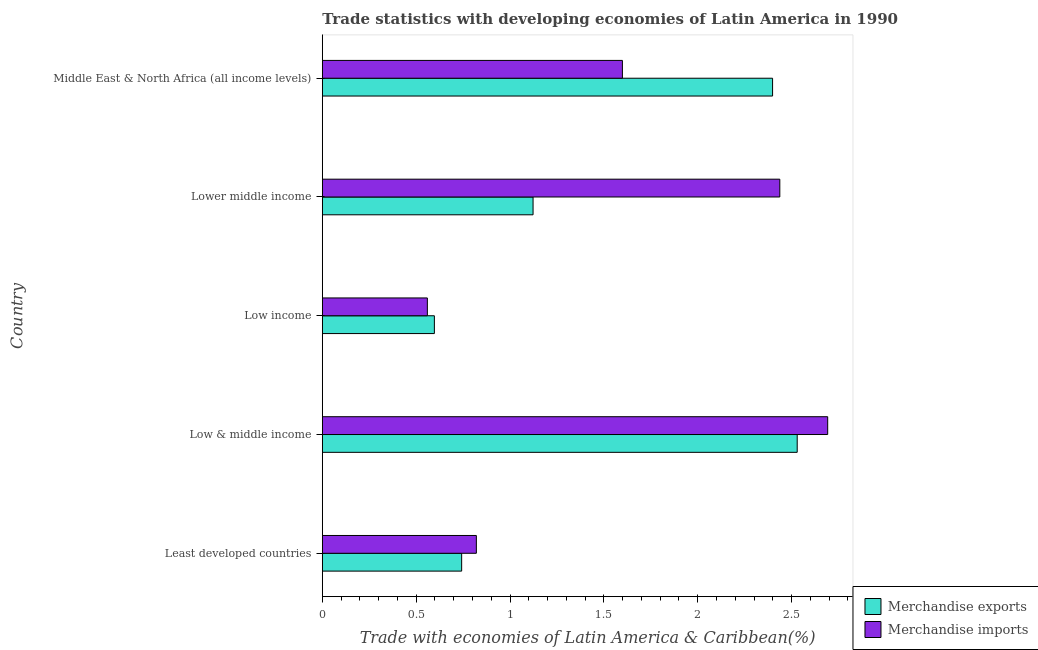How many groups of bars are there?
Ensure brevity in your answer.  5. How many bars are there on the 4th tick from the top?
Your response must be concise. 2. What is the label of the 1st group of bars from the top?
Ensure brevity in your answer.  Middle East & North Africa (all income levels). In how many cases, is the number of bars for a given country not equal to the number of legend labels?
Give a very brief answer. 0. What is the merchandise imports in Low income?
Provide a short and direct response. 0.56. Across all countries, what is the maximum merchandise imports?
Your answer should be compact. 2.69. Across all countries, what is the minimum merchandise exports?
Your response must be concise. 0.6. In which country was the merchandise exports minimum?
Your answer should be compact. Low income. What is the total merchandise exports in the graph?
Make the answer very short. 7.39. What is the difference between the merchandise exports in Least developed countries and that in Lower middle income?
Make the answer very short. -0.38. What is the difference between the merchandise exports in Least developed countries and the merchandise imports in Low income?
Give a very brief answer. 0.18. What is the average merchandise exports per country?
Your answer should be compact. 1.48. What is the difference between the merchandise exports and merchandise imports in Least developed countries?
Make the answer very short. -0.08. What is the ratio of the merchandise exports in Lower middle income to that in Middle East & North Africa (all income levels)?
Offer a terse response. 0.47. Is the difference between the merchandise exports in Low & middle income and Lower middle income greater than the difference between the merchandise imports in Low & middle income and Lower middle income?
Make the answer very short. Yes. What is the difference between the highest and the second highest merchandise exports?
Provide a succinct answer. 0.13. What is the difference between the highest and the lowest merchandise imports?
Provide a succinct answer. 2.13. What does the 1st bar from the top in Least developed countries represents?
Your answer should be compact. Merchandise imports. How many bars are there?
Your response must be concise. 10. How many countries are there in the graph?
Your answer should be very brief. 5. What is the difference between two consecutive major ticks on the X-axis?
Provide a short and direct response. 0.5. Are the values on the major ticks of X-axis written in scientific E-notation?
Ensure brevity in your answer.  No. Does the graph contain any zero values?
Offer a terse response. No. Does the graph contain grids?
Provide a succinct answer. No. Where does the legend appear in the graph?
Your answer should be compact. Bottom right. How many legend labels are there?
Provide a succinct answer. 2. What is the title of the graph?
Offer a terse response. Trade statistics with developing economies of Latin America in 1990. What is the label or title of the X-axis?
Offer a terse response. Trade with economies of Latin America & Caribbean(%). What is the label or title of the Y-axis?
Your response must be concise. Country. What is the Trade with economies of Latin America & Caribbean(%) of Merchandise exports in Least developed countries?
Ensure brevity in your answer.  0.74. What is the Trade with economies of Latin America & Caribbean(%) in Merchandise imports in Least developed countries?
Ensure brevity in your answer.  0.82. What is the Trade with economies of Latin America & Caribbean(%) in Merchandise exports in Low & middle income?
Provide a succinct answer. 2.53. What is the Trade with economies of Latin America & Caribbean(%) in Merchandise imports in Low & middle income?
Your answer should be very brief. 2.69. What is the Trade with economies of Latin America & Caribbean(%) of Merchandise exports in Low income?
Ensure brevity in your answer.  0.6. What is the Trade with economies of Latin America & Caribbean(%) of Merchandise imports in Low income?
Offer a terse response. 0.56. What is the Trade with economies of Latin America & Caribbean(%) of Merchandise exports in Lower middle income?
Offer a very short reply. 1.12. What is the Trade with economies of Latin America & Caribbean(%) of Merchandise imports in Lower middle income?
Ensure brevity in your answer.  2.44. What is the Trade with economies of Latin America & Caribbean(%) in Merchandise exports in Middle East & North Africa (all income levels)?
Offer a very short reply. 2.4. What is the Trade with economies of Latin America & Caribbean(%) in Merchandise imports in Middle East & North Africa (all income levels)?
Offer a very short reply. 1.6. Across all countries, what is the maximum Trade with economies of Latin America & Caribbean(%) in Merchandise exports?
Provide a succinct answer. 2.53. Across all countries, what is the maximum Trade with economies of Latin America & Caribbean(%) in Merchandise imports?
Your answer should be very brief. 2.69. Across all countries, what is the minimum Trade with economies of Latin America & Caribbean(%) in Merchandise exports?
Provide a succinct answer. 0.6. Across all countries, what is the minimum Trade with economies of Latin America & Caribbean(%) of Merchandise imports?
Keep it short and to the point. 0.56. What is the total Trade with economies of Latin America & Caribbean(%) in Merchandise exports in the graph?
Offer a very short reply. 7.39. What is the total Trade with economies of Latin America & Caribbean(%) in Merchandise imports in the graph?
Your response must be concise. 8.11. What is the difference between the Trade with economies of Latin America & Caribbean(%) in Merchandise exports in Least developed countries and that in Low & middle income?
Offer a very short reply. -1.79. What is the difference between the Trade with economies of Latin America & Caribbean(%) of Merchandise imports in Least developed countries and that in Low & middle income?
Provide a short and direct response. -1.87. What is the difference between the Trade with economies of Latin America & Caribbean(%) of Merchandise exports in Least developed countries and that in Low income?
Offer a very short reply. 0.15. What is the difference between the Trade with economies of Latin America & Caribbean(%) of Merchandise imports in Least developed countries and that in Low income?
Offer a terse response. 0.26. What is the difference between the Trade with economies of Latin America & Caribbean(%) of Merchandise exports in Least developed countries and that in Lower middle income?
Offer a very short reply. -0.38. What is the difference between the Trade with economies of Latin America & Caribbean(%) of Merchandise imports in Least developed countries and that in Lower middle income?
Your response must be concise. -1.62. What is the difference between the Trade with economies of Latin America & Caribbean(%) of Merchandise exports in Least developed countries and that in Middle East & North Africa (all income levels)?
Ensure brevity in your answer.  -1.66. What is the difference between the Trade with economies of Latin America & Caribbean(%) of Merchandise imports in Least developed countries and that in Middle East & North Africa (all income levels)?
Offer a very short reply. -0.78. What is the difference between the Trade with economies of Latin America & Caribbean(%) of Merchandise exports in Low & middle income and that in Low income?
Keep it short and to the point. 1.93. What is the difference between the Trade with economies of Latin America & Caribbean(%) of Merchandise imports in Low & middle income and that in Low income?
Your answer should be compact. 2.13. What is the difference between the Trade with economies of Latin America & Caribbean(%) in Merchandise exports in Low & middle income and that in Lower middle income?
Offer a very short reply. 1.41. What is the difference between the Trade with economies of Latin America & Caribbean(%) in Merchandise imports in Low & middle income and that in Lower middle income?
Offer a terse response. 0.26. What is the difference between the Trade with economies of Latin America & Caribbean(%) of Merchandise exports in Low & middle income and that in Middle East & North Africa (all income levels)?
Your response must be concise. 0.13. What is the difference between the Trade with economies of Latin America & Caribbean(%) in Merchandise imports in Low & middle income and that in Middle East & North Africa (all income levels)?
Make the answer very short. 1.09. What is the difference between the Trade with economies of Latin America & Caribbean(%) in Merchandise exports in Low income and that in Lower middle income?
Ensure brevity in your answer.  -0.53. What is the difference between the Trade with economies of Latin America & Caribbean(%) of Merchandise imports in Low income and that in Lower middle income?
Ensure brevity in your answer.  -1.88. What is the difference between the Trade with economies of Latin America & Caribbean(%) of Merchandise exports in Low income and that in Middle East & North Africa (all income levels)?
Give a very brief answer. -1.8. What is the difference between the Trade with economies of Latin America & Caribbean(%) in Merchandise imports in Low income and that in Middle East & North Africa (all income levels)?
Ensure brevity in your answer.  -1.04. What is the difference between the Trade with economies of Latin America & Caribbean(%) in Merchandise exports in Lower middle income and that in Middle East & North Africa (all income levels)?
Ensure brevity in your answer.  -1.28. What is the difference between the Trade with economies of Latin America & Caribbean(%) in Merchandise imports in Lower middle income and that in Middle East & North Africa (all income levels)?
Provide a succinct answer. 0.84. What is the difference between the Trade with economies of Latin America & Caribbean(%) in Merchandise exports in Least developed countries and the Trade with economies of Latin America & Caribbean(%) in Merchandise imports in Low & middle income?
Keep it short and to the point. -1.95. What is the difference between the Trade with economies of Latin America & Caribbean(%) of Merchandise exports in Least developed countries and the Trade with economies of Latin America & Caribbean(%) of Merchandise imports in Low income?
Offer a terse response. 0.18. What is the difference between the Trade with economies of Latin America & Caribbean(%) of Merchandise exports in Least developed countries and the Trade with economies of Latin America & Caribbean(%) of Merchandise imports in Lower middle income?
Ensure brevity in your answer.  -1.69. What is the difference between the Trade with economies of Latin America & Caribbean(%) in Merchandise exports in Least developed countries and the Trade with economies of Latin America & Caribbean(%) in Merchandise imports in Middle East & North Africa (all income levels)?
Ensure brevity in your answer.  -0.86. What is the difference between the Trade with economies of Latin America & Caribbean(%) in Merchandise exports in Low & middle income and the Trade with economies of Latin America & Caribbean(%) in Merchandise imports in Low income?
Your response must be concise. 1.97. What is the difference between the Trade with economies of Latin America & Caribbean(%) of Merchandise exports in Low & middle income and the Trade with economies of Latin America & Caribbean(%) of Merchandise imports in Lower middle income?
Your answer should be very brief. 0.09. What is the difference between the Trade with economies of Latin America & Caribbean(%) of Merchandise exports in Low & middle income and the Trade with economies of Latin America & Caribbean(%) of Merchandise imports in Middle East & North Africa (all income levels)?
Give a very brief answer. 0.93. What is the difference between the Trade with economies of Latin America & Caribbean(%) in Merchandise exports in Low income and the Trade with economies of Latin America & Caribbean(%) in Merchandise imports in Lower middle income?
Your response must be concise. -1.84. What is the difference between the Trade with economies of Latin America & Caribbean(%) in Merchandise exports in Low income and the Trade with economies of Latin America & Caribbean(%) in Merchandise imports in Middle East & North Africa (all income levels)?
Make the answer very short. -1. What is the difference between the Trade with economies of Latin America & Caribbean(%) in Merchandise exports in Lower middle income and the Trade with economies of Latin America & Caribbean(%) in Merchandise imports in Middle East & North Africa (all income levels)?
Your answer should be compact. -0.48. What is the average Trade with economies of Latin America & Caribbean(%) in Merchandise exports per country?
Give a very brief answer. 1.48. What is the average Trade with economies of Latin America & Caribbean(%) of Merchandise imports per country?
Your response must be concise. 1.62. What is the difference between the Trade with economies of Latin America & Caribbean(%) of Merchandise exports and Trade with economies of Latin America & Caribbean(%) of Merchandise imports in Least developed countries?
Keep it short and to the point. -0.08. What is the difference between the Trade with economies of Latin America & Caribbean(%) of Merchandise exports and Trade with economies of Latin America & Caribbean(%) of Merchandise imports in Low & middle income?
Give a very brief answer. -0.16. What is the difference between the Trade with economies of Latin America & Caribbean(%) of Merchandise exports and Trade with economies of Latin America & Caribbean(%) of Merchandise imports in Low income?
Keep it short and to the point. 0.04. What is the difference between the Trade with economies of Latin America & Caribbean(%) of Merchandise exports and Trade with economies of Latin America & Caribbean(%) of Merchandise imports in Lower middle income?
Ensure brevity in your answer.  -1.31. What is the difference between the Trade with economies of Latin America & Caribbean(%) in Merchandise exports and Trade with economies of Latin America & Caribbean(%) in Merchandise imports in Middle East & North Africa (all income levels)?
Keep it short and to the point. 0.8. What is the ratio of the Trade with economies of Latin America & Caribbean(%) of Merchandise exports in Least developed countries to that in Low & middle income?
Provide a succinct answer. 0.29. What is the ratio of the Trade with economies of Latin America & Caribbean(%) in Merchandise imports in Least developed countries to that in Low & middle income?
Offer a terse response. 0.3. What is the ratio of the Trade with economies of Latin America & Caribbean(%) in Merchandise exports in Least developed countries to that in Low income?
Your answer should be very brief. 1.24. What is the ratio of the Trade with economies of Latin America & Caribbean(%) of Merchandise imports in Least developed countries to that in Low income?
Make the answer very short. 1.47. What is the ratio of the Trade with economies of Latin America & Caribbean(%) in Merchandise exports in Least developed countries to that in Lower middle income?
Give a very brief answer. 0.66. What is the ratio of the Trade with economies of Latin America & Caribbean(%) of Merchandise imports in Least developed countries to that in Lower middle income?
Make the answer very short. 0.34. What is the ratio of the Trade with economies of Latin America & Caribbean(%) of Merchandise exports in Least developed countries to that in Middle East & North Africa (all income levels)?
Offer a terse response. 0.31. What is the ratio of the Trade with economies of Latin America & Caribbean(%) in Merchandise imports in Least developed countries to that in Middle East & North Africa (all income levels)?
Give a very brief answer. 0.51. What is the ratio of the Trade with economies of Latin America & Caribbean(%) in Merchandise exports in Low & middle income to that in Low income?
Provide a short and direct response. 4.24. What is the ratio of the Trade with economies of Latin America & Caribbean(%) in Merchandise imports in Low & middle income to that in Low income?
Your answer should be compact. 4.81. What is the ratio of the Trade with economies of Latin America & Caribbean(%) of Merchandise exports in Low & middle income to that in Lower middle income?
Ensure brevity in your answer.  2.25. What is the ratio of the Trade with economies of Latin America & Caribbean(%) of Merchandise imports in Low & middle income to that in Lower middle income?
Offer a terse response. 1.1. What is the ratio of the Trade with economies of Latin America & Caribbean(%) in Merchandise exports in Low & middle income to that in Middle East & North Africa (all income levels)?
Your answer should be compact. 1.05. What is the ratio of the Trade with economies of Latin America & Caribbean(%) in Merchandise imports in Low & middle income to that in Middle East & North Africa (all income levels)?
Your answer should be very brief. 1.68. What is the ratio of the Trade with economies of Latin America & Caribbean(%) of Merchandise exports in Low income to that in Lower middle income?
Your answer should be very brief. 0.53. What is the ratio of the Trade with economies of Latin America & Caribbean(%) in Merchandise imports in Low income to that in Lower middle income?
Make the answer very short. 0.23. What is the ratio of the Trade with economies of Latin America & Caribbean(%) in Merchandise exports in Low income to that in Middle East & North Africa (all income levels)?
Your answer should be very brief. 0.25. What is the ratio of the Trade with economies of Latin America & Caribbean(%) in Merchandise exports in Lower middle income to that in Middle East & North Africa (all income levels)?
Offer a very short reply. 0.47. What is the ratio of the Trade with economies of Latin America & Caribbean(%) in Merchandise imports in Lower middle income to that in Middle East & North Africa (all income levels)?
Make the answer very short. 1.52. What is the difference between the highest and the second highest Trade with economies of Latin America & Caribbean(%) in Merchandise exports?
Your answer should be very brief. 0.13. What is the difference between the highest and the second highest Trade with economies of Latin America & Caribbean(%) in Merchandise imports?
Your answer should be compact. 0.26. What is the difference between the highest and the lowest Trade with economies of Latin America & Caribbean(%) of Merchandise exports?
Provide a short and direct response. 1.93. What is the difference between the highest and the lowest Trade with economies of Latin America & Caribbean(%) of Merchandise imports?
Make the answer very short. 2.13. 